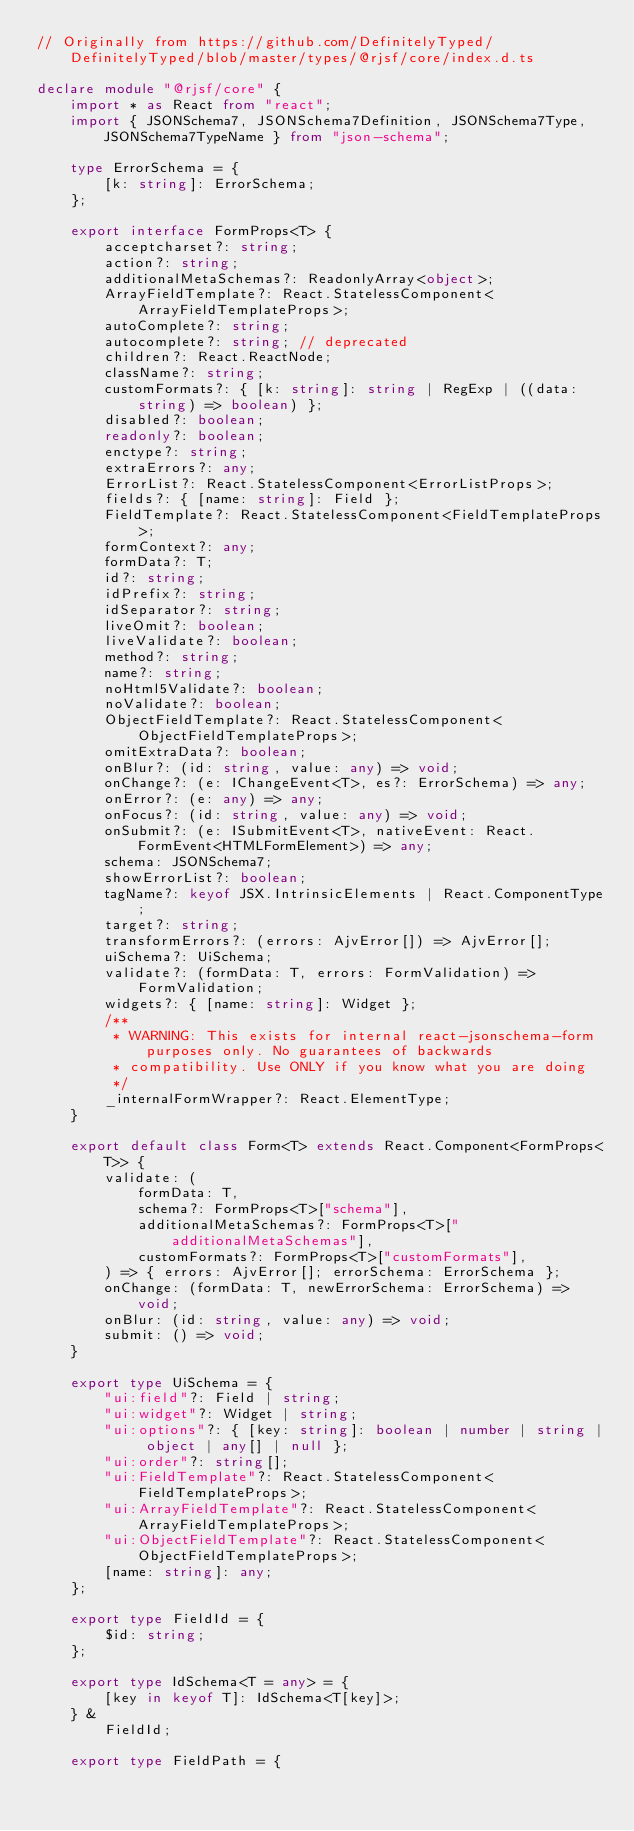Convert code to text. <code><loc_0><loc_0><loc_500><loc_500><_TypeScript_>// Originally from https://github.com/DefinitelyTyped/DefinitelyTyped/blob/master/types/@rjsf/core/index.d.ts

declare module "@rjsf/core" {
    import * as React from "react";
    import { JSONSchema7, JSONSchema7Definition, JSONSchema7Type, JSONSchema7TypeName } from "json-schema";

    type ErrorSchema = {
        [k: string]: ErrorSchema;
    };

    export interface FormProps<T> {
        acceptcharset?: string;
        action?: string;
        additionalMetaSchemas?: ReadonlyArray<object>;
        ArrayFieldTemplate?: React.StatelessComponent<ArrayFieldTemplateProps>;
        autoComplete?: string;
        autocomplete?: string; // deprecated
        children?: React.ReactNode;
        className?: string;
        customFormats?: { [k: string]: string | RegExp | ((data: string) => boolean) };
        disabled?: boolean;
        readonly?: boolean;
        enctype?: string;
        extraErrors?: any;
        ErrorList?: React.StatelessComponent<ErrorListProps>;
        fields?: { [name: string]: Field };
        FieldTemplate?: React.StatelessComponent<FieldTemplateProps>;
        formContext?: any;
        formData?: T;
        id?: string;
        idPrefix?: string;
        idSeparator?: string;
        liveOmit?: boolean;
        liveValidate?: boolean;
        method?: string;
        name?: string;
        noHtml5Validate?: boolean;
        noValidate?: boolean;
        ObjectFieldTemplate?: React.StatelessComponent<ObjectFieldTemplateProps>;
        omitExtraData?: boolean;
        onBlur?: (id: string, value: any) => void;
        onChange?: (e: IChangeEvent<T>, es?: ErrorSchema) => any;
        onError?: (e: any) => any;
        onFocus?: (id: string, value: any) => void;
        onSubmit?: (e: ISubmitEvent<T>, nativeEvent: React.FormEvent<HTMLFormElement>) => any;
        schema: JSONSchema7;
        showErrorList?: boolean;
        tagName?: keyof JSX.IntrinsicElements | React.ComponentType;
        target?: string;
        transformErrors?: (errors: AjvError[]) => AjvError[];
        uiSchema?: UiSchema;
        validate?: (formData: T, errors: FormValidation) => FormValidation;
        widgets?: { [name: string]: Widget };
        /**
         * WARNING: This exists for internal react-jsonschema-form purposes only. No guarantees of backwards
         * compatibility. Use ONLY if you know what you are doing
         */
        _internalFormWrapper?: React.ElementType;
    }

    export default class Form<T> extends React.Component<FormProps<T>> {
        validate: (
            formData: T,
            schema?: FormProps<T>["schema"],
            additionalMetaSchemas?: FormProps<T>["additionalMetaSchemas"],
            customFormats?: FormProps<T>["customFormats"],
        ) => { errors: AjvError[]; errorSchema: ErrorSchema };
        onChange: (formData: T, newErrorSchema: ErrorSchema) => void;
        onBlur: (id: string, value: any) => void;
        submit: () => void;
    }

    export type UiSchema = {
        "ui:field"?: Field | string;
        "ui:widget"?: Widget | string;
        "ui:options"?: { [key: string]: boolean | number | string | object | any[] | null };
        "ui:order"?: string[];
        "ui:FieldTemplate"?: React.StatelessComponent<FieldTemplateProps>;
        "ui:ArrayFieldTemplate"?: React.StatelessComponent<ArrayFieldTemplateProps>;
        "ui:ObjectFieldTemplate"?: React.StatelessComponent<ObjectFieldTemplateProps>;
        [name: string]: any;
    };

    export type FieldId = {
        $id: string;
    };

    export type IdSchema<T = any> = {
        [key in keyof T]: IdSchema<T[key]>;
    } &
        FieldId;

    export type FieldPath = {</code> 